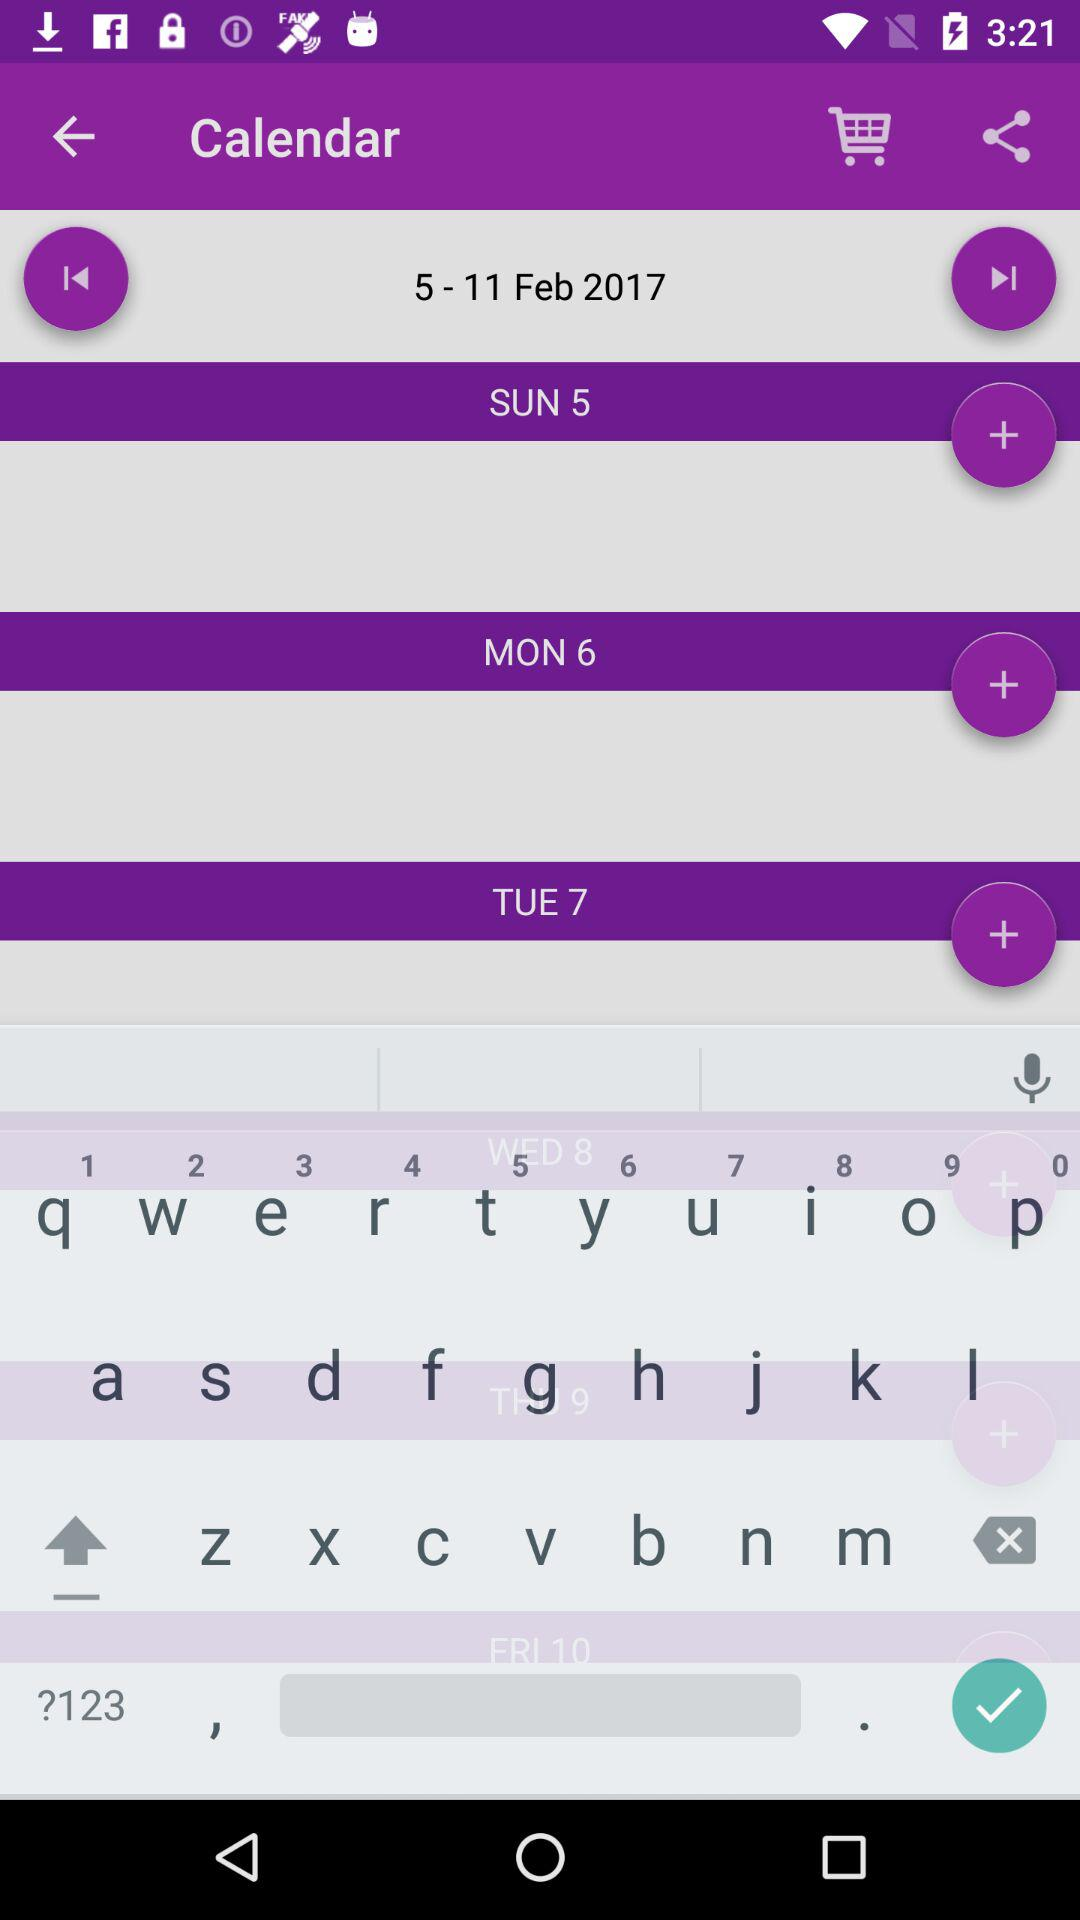How many calendar events are there?
Answer the question using a single word or phrase. 3 